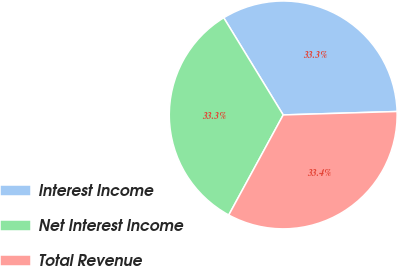Convert chart to OTSL. <chart><loc_0><loc_0><loc_500><loc_500><pie_chart><fcel>Interest Income<fcel>Net Interest Income<fcel>Total Revenue<nl><fcel>33.26%<fcel>33.33%<fcel>33.41%<nl></chart> 